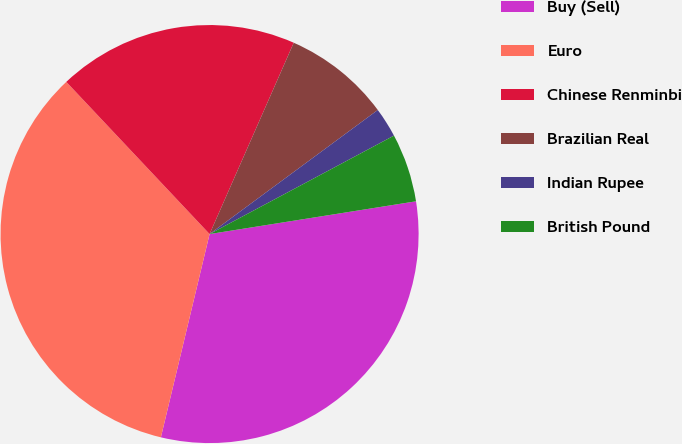Convert chart to OTSL. <chart><loc_0><loc_0><loc_500><loc_500><pie_chart><fcel>Buy (Sell)<fcel>Euro<fcel>Chinese Renminbi<fcel>Brazilian Real<fcel>Indian Rupee<fcel>British Pound<nl><fcel>31.25%<fcel>34.24%<fcel>18.62%<fcel>8.29%<fcel>2.31%<fcel>5.3%<nl></chart> 